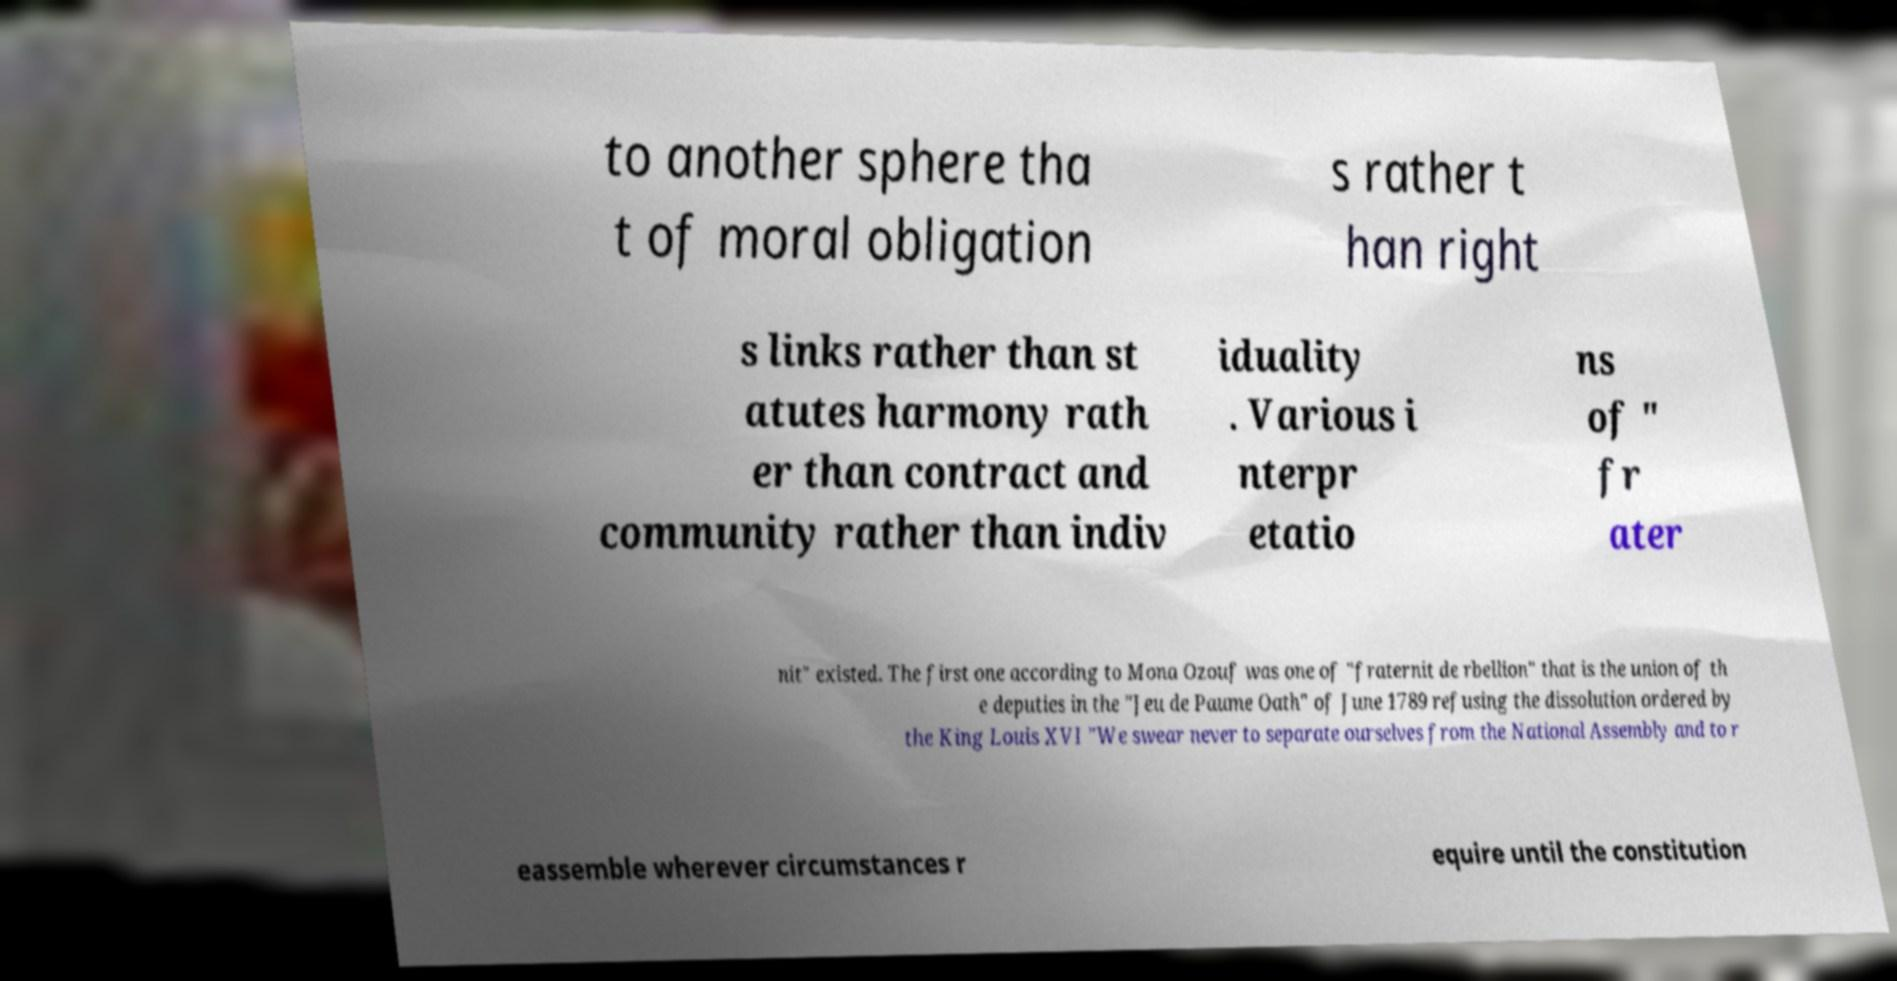Please identify and transcribe the text found in this image. to another sphere tha t of moral obligation s rather t han right s links rather than st atutes harmony rath er than contract and community rather than indiv iduality . Various i nterpr etatio ns of " fr ater nit" existed. The first one according to Mona Ozouf was one of "fraternit de rbellion" that is the union of th e deputies in the "Jeu de Paume Oath" of June 1789 refusing the dissolution ordered by the King Louis XVI "We swear never to separate ourselves from the National Assembly and to r eassemble wherever circumstances r equire until the constitution 